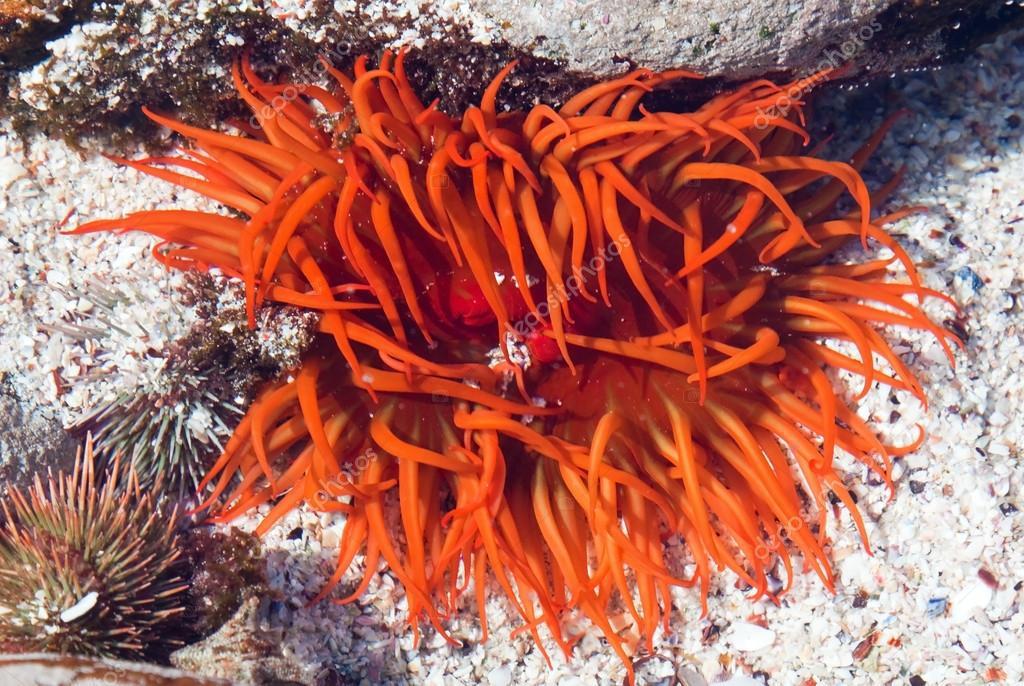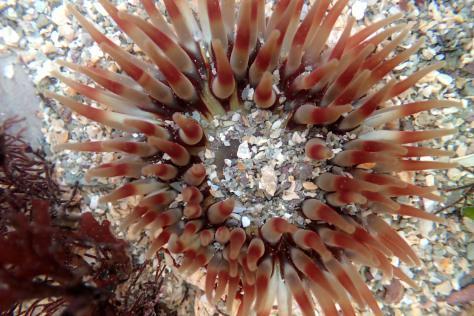The first image is the image on the left, the second image is the image on the right. Considering the images on both sides, is "At least one image features several anemone." valid? Answer yes or no. No. The first image is the image on the left, the second image is the image on the right. For the images shown, is this caption "An image includes an anemone with pink tendrils trailing down from a darker stout red stalk." true? Answer yes or no. No. 